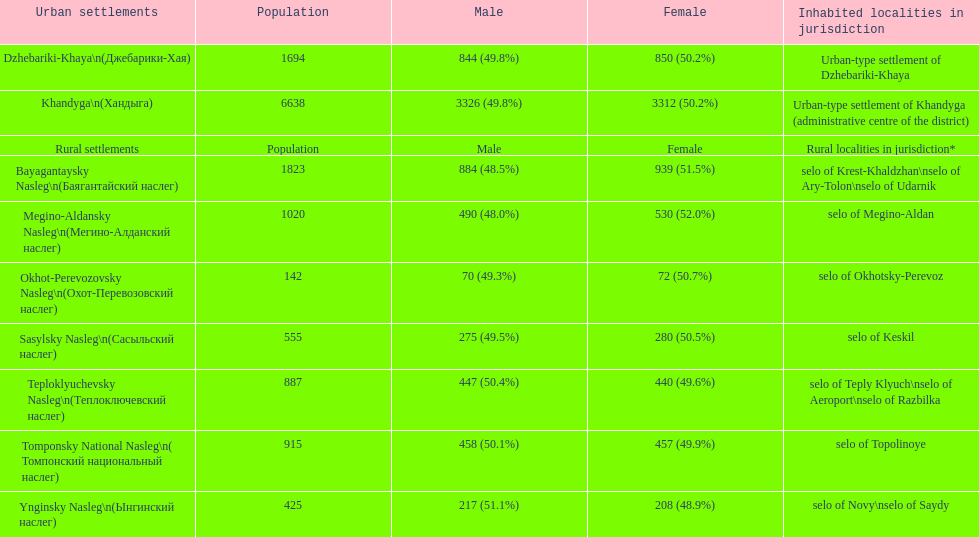In which rural area is the male population the most significant? Bayagantaysky Nasleg (Áàÿãàíòàéñêèé íàñëåã). 